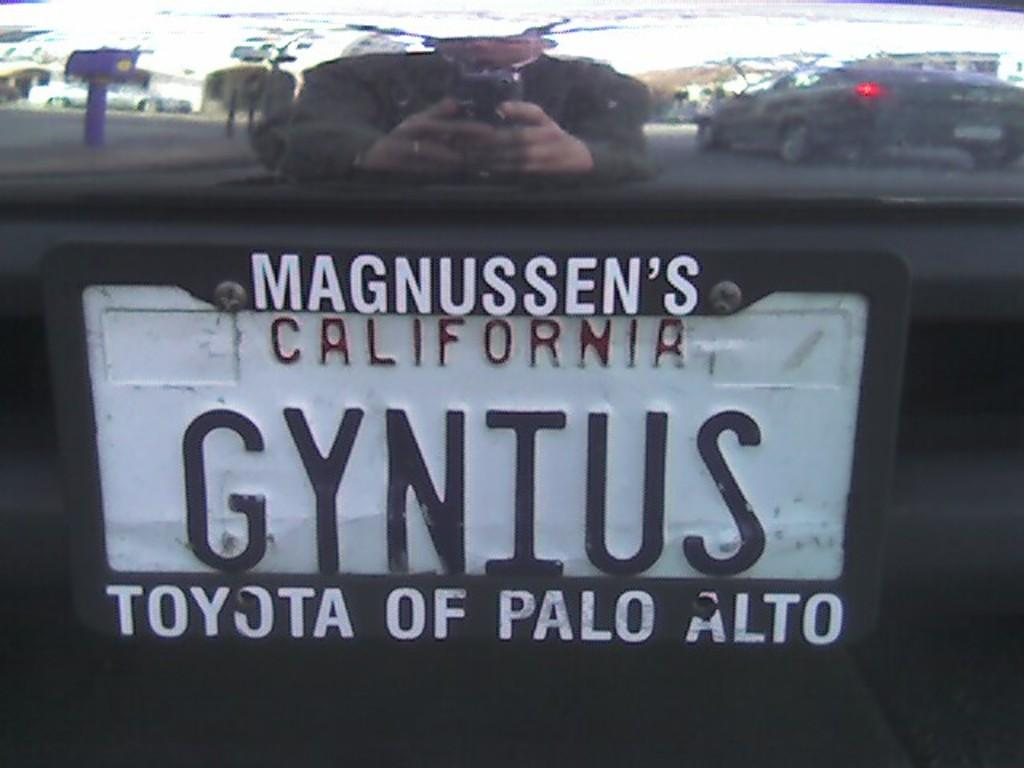<image>
Offer a succinct explanation of the picture presented. A California licence plate with the word Magnussen's on the top. 